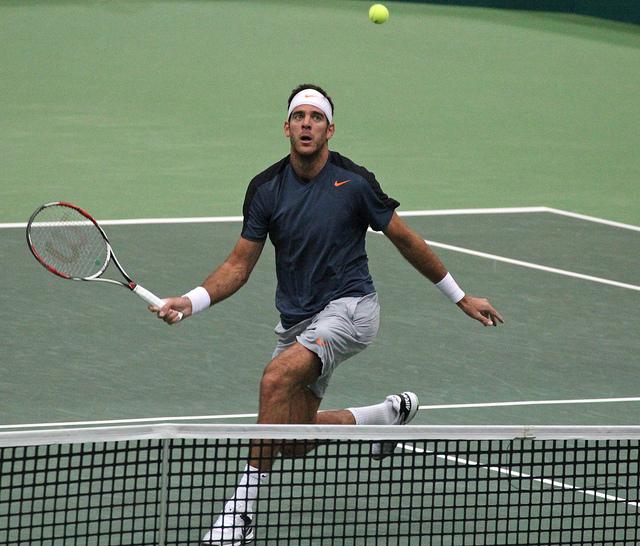What sport is this?
Give a very brief answer. Tennis. What color is the man's shirt?
Be succinct. Black. Is the man running toward the ball?
Short answer required. Yes. 